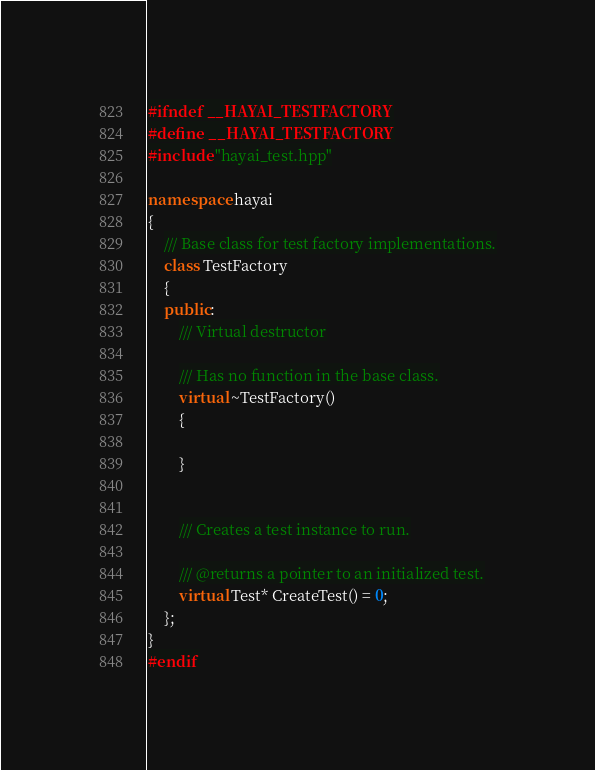Convert code to text. <code><loc_0><loc_0><loc_500><loc_500><_C++_>#ifndef __HAYAI_TESTFACTORY
#define __HAYAI_TESTFACTORY
#include "hayai_test.hpp"

namespace hayai
{
    /// Base class for test factory implementations.
    class TestFactory
    {
    public:
        /// Virtual destructor

        /// Has no function in the base class.
        virtual ~TestFactory()
        {

        }


        /// Creates a test instance to run.

        /// @returns a pointer to an initialized test.
        virtual Test* CreateTest() = 0;
    };
}
#endif
</code> 